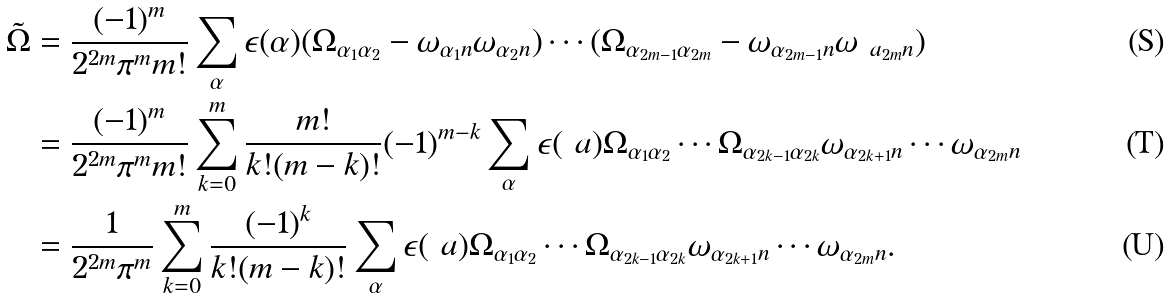<formula> <loc_0><loc_0><loc_500><loc_500>\tilde { \Omega } & = \frac { ( - 1 ) ^ { m } } { 2 ^ { 2 m } \pi ^ { m } m ! } \sum _ { \alpha } \epsilon ( \alpha ) ( \Omega _ { \alpha _ { 1 } \alpha _ { 2 } } - \omega _ { \alpha _ { 1 } n } \omega _ { \alpha _ { 2 } n } ) \cdots ( \Omega _ { \alpha _ { 2 m - 1 } \alpha _ { 2 m } } - \omega _ { \alpha _ { 2 m - 1 } n } \omega _ { \ a _ { 2 m } n } ) \\ & = \frac { ( - 1 ) ^ { m } } { 2 ^ { 2 m } \pi ^ { m } m ! } \sum _ { k = 0 } ^ { m } \frac { m ! } { k ! ( m - k ) ! } ( - 1 ) ^ { m - k } \sum _ { \alpha } \epsilon ( \ a ) \Omega _ { \alpha _ { 1 } \alpha _ { 2 } } \cdots \Omega _ { \alpha _ { 2 k - 1 } \alpha _ { 2 k } } \omega _ { \alpha _ { 2 k + 1 } n } \cdots \omega _ { \alpha _ { 2 m } n } \\ & = \frac { 1 } { 2 ^ { 2 m } \pi ^ { m } } \sum _ { k = 0 } ^ { m } \frac { ( - 1 ) ^ { k } } { k ! ( m - k ) ! } \sum _ { \alpha } \epsilon ( \ a ) \Omega _ { \alpha _ { 1 } \alpha _ { 2 } } \cdots \Omega _ { \alpha _ { 2 k - 1 } \alpha _ { 2 k } } \omega _ { \alpha _ { 2 k + 1 } n } \cdots \omega _ { \alpha _ { 2 m } n } .</formula> 